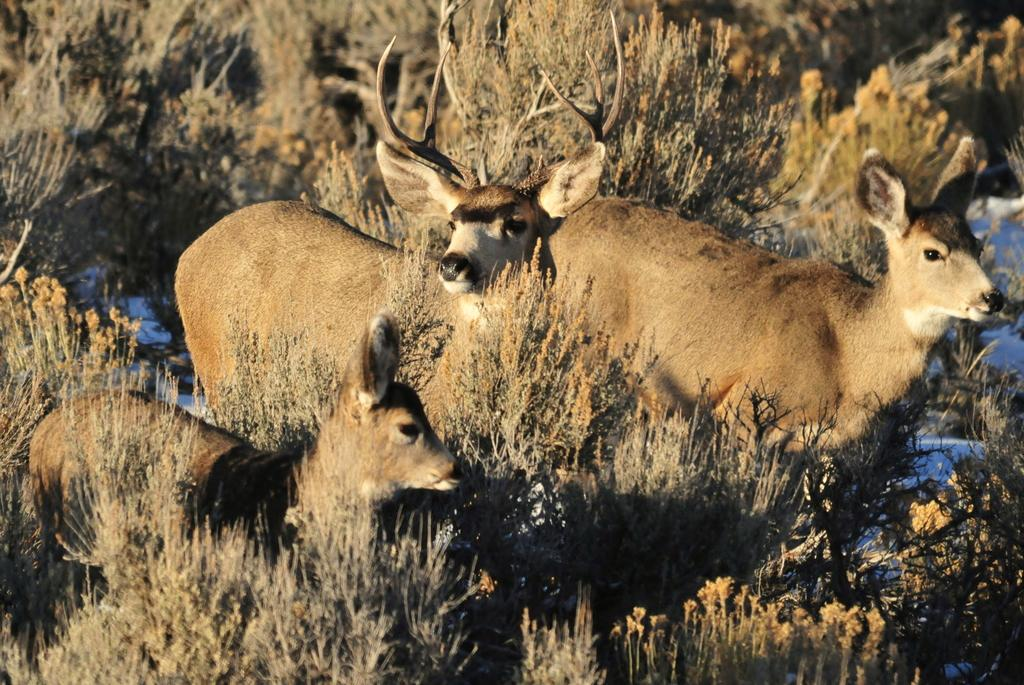What types of living organisms can be seen in the image? There are animals in the image. What can be seen beneath the animals in the image? The ground is visible in the image. What type of vegetation is present on the ground in the image? There are plants on the ground in the image. What else can be seen in the image besides the animals, ground, and plants? There are objects present in the image. What type of lunch is being served in the image? There is no lunch present in the image; it features animals, ground, plants, and objects. What town is visible in the image? There is no town present in the image; it features animals, ground, plants, and objects. 